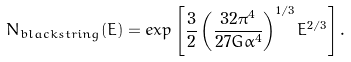<formula> <loc_0><loc_0><loc_500><loc_500>N _ { b l a c k s t r i n g } ( E ) = e x p \left [ \frac { 3 } { 2 } \left ( \frac { 3 2 \pi ^ { 4 } } { 2 7 G \alpha ^ { 4 } } \right ) ^ { 1 / 3 } E ^ { 2 / 3 } \right ] .</formula> 